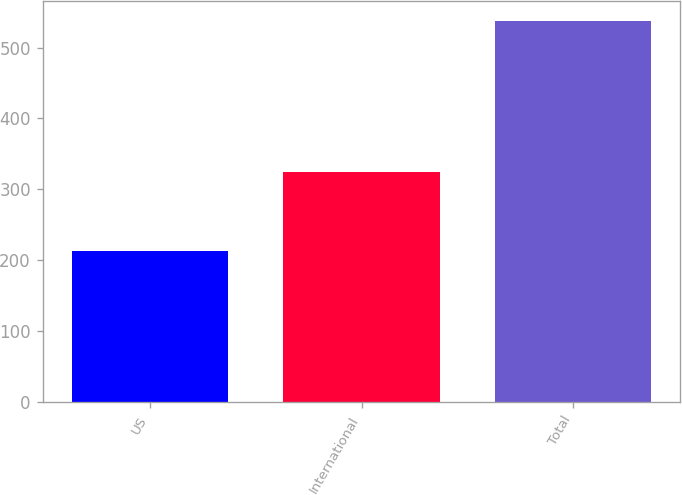<chart> <loc_0><loc_0><loc_500><loc_500><bar_chart><fcel>US<fcel>International<fcel>Total<nl><fcel>214<fcel>324<fcel>538<nl></chart> 